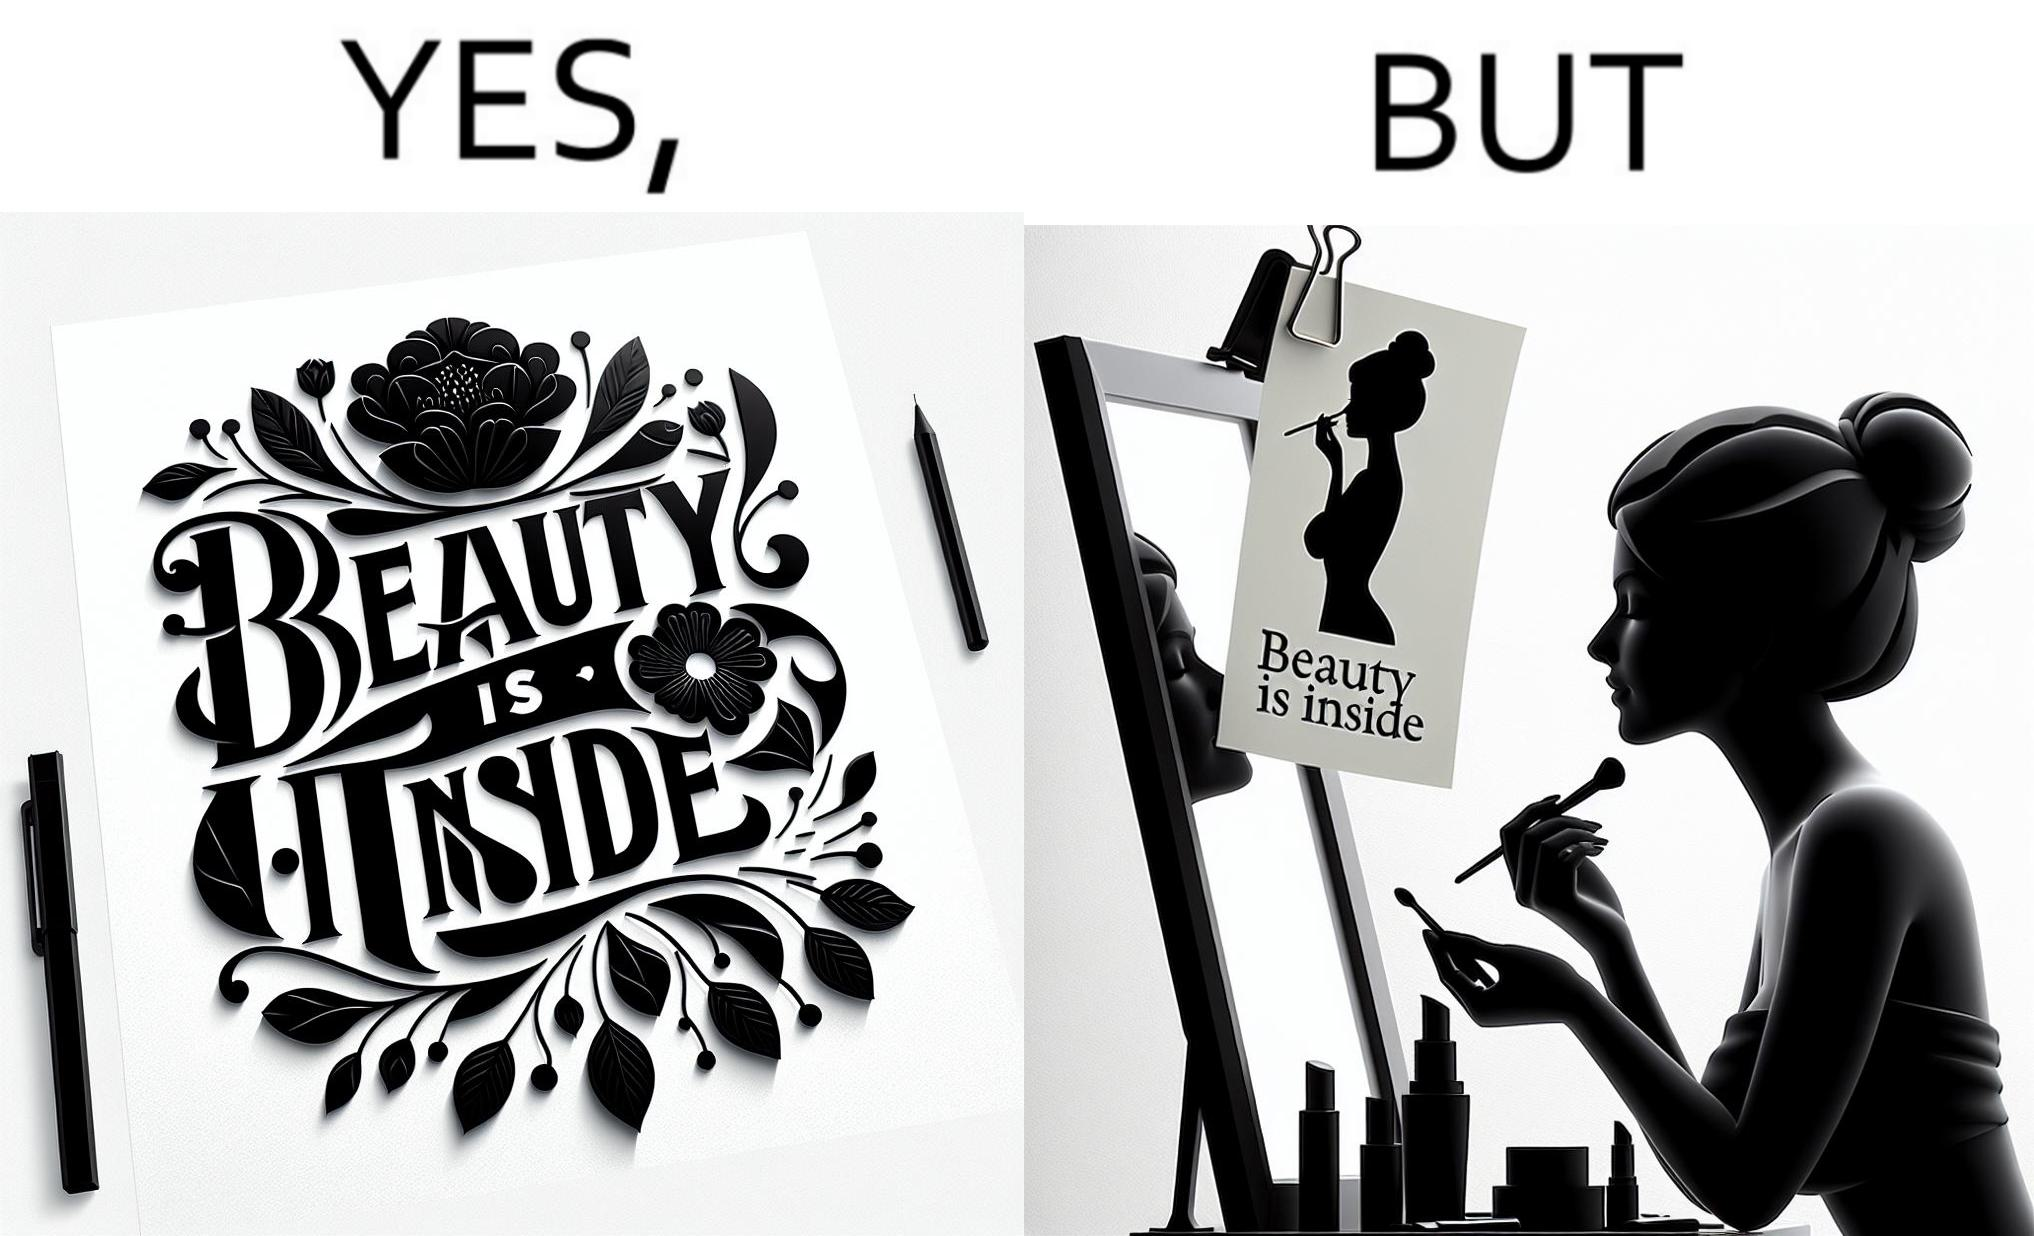Is this image satirical or non-satirical? Yes, this image is satirical. 